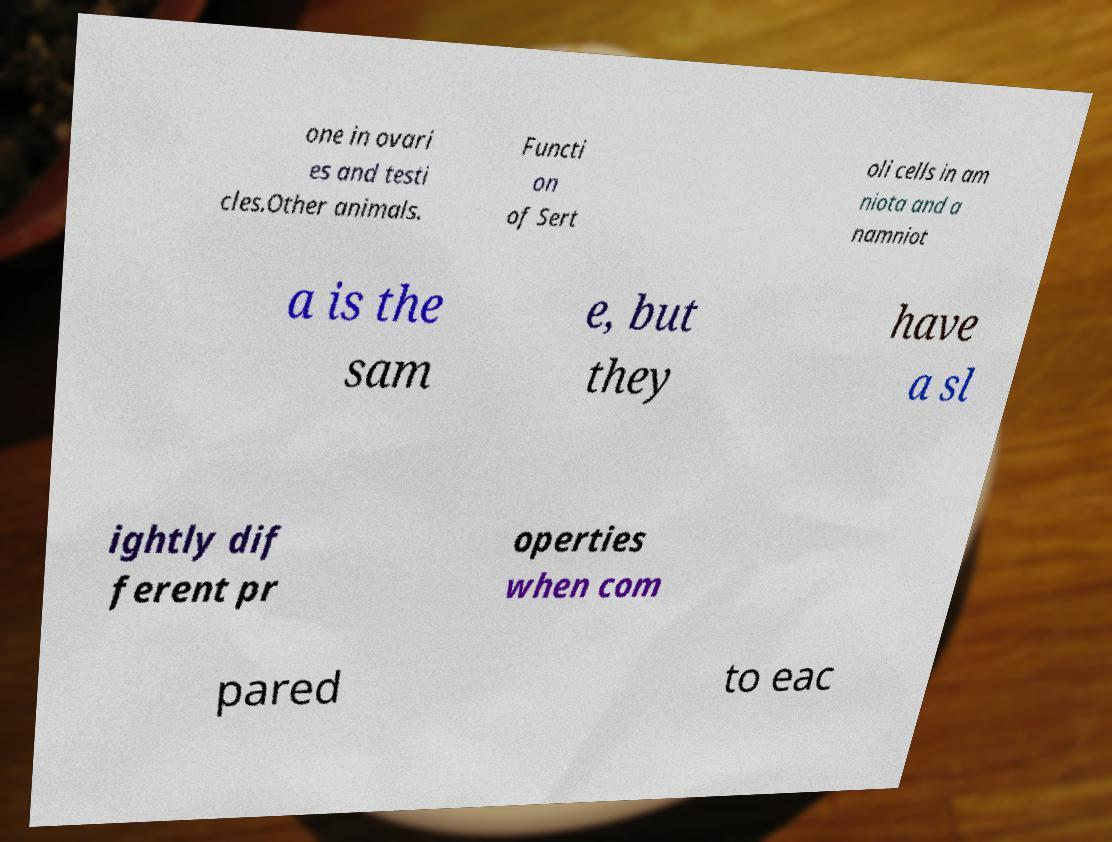There's text embedded in this image that I need extracted. Can you transcribe it verbatim? one in ovari es and testi cles.Other animals. Functi on of Sert oli cells in am niota and a namniot a is the sam e, but they have a sl ightly dif ferent pr operties when com pared to eac 